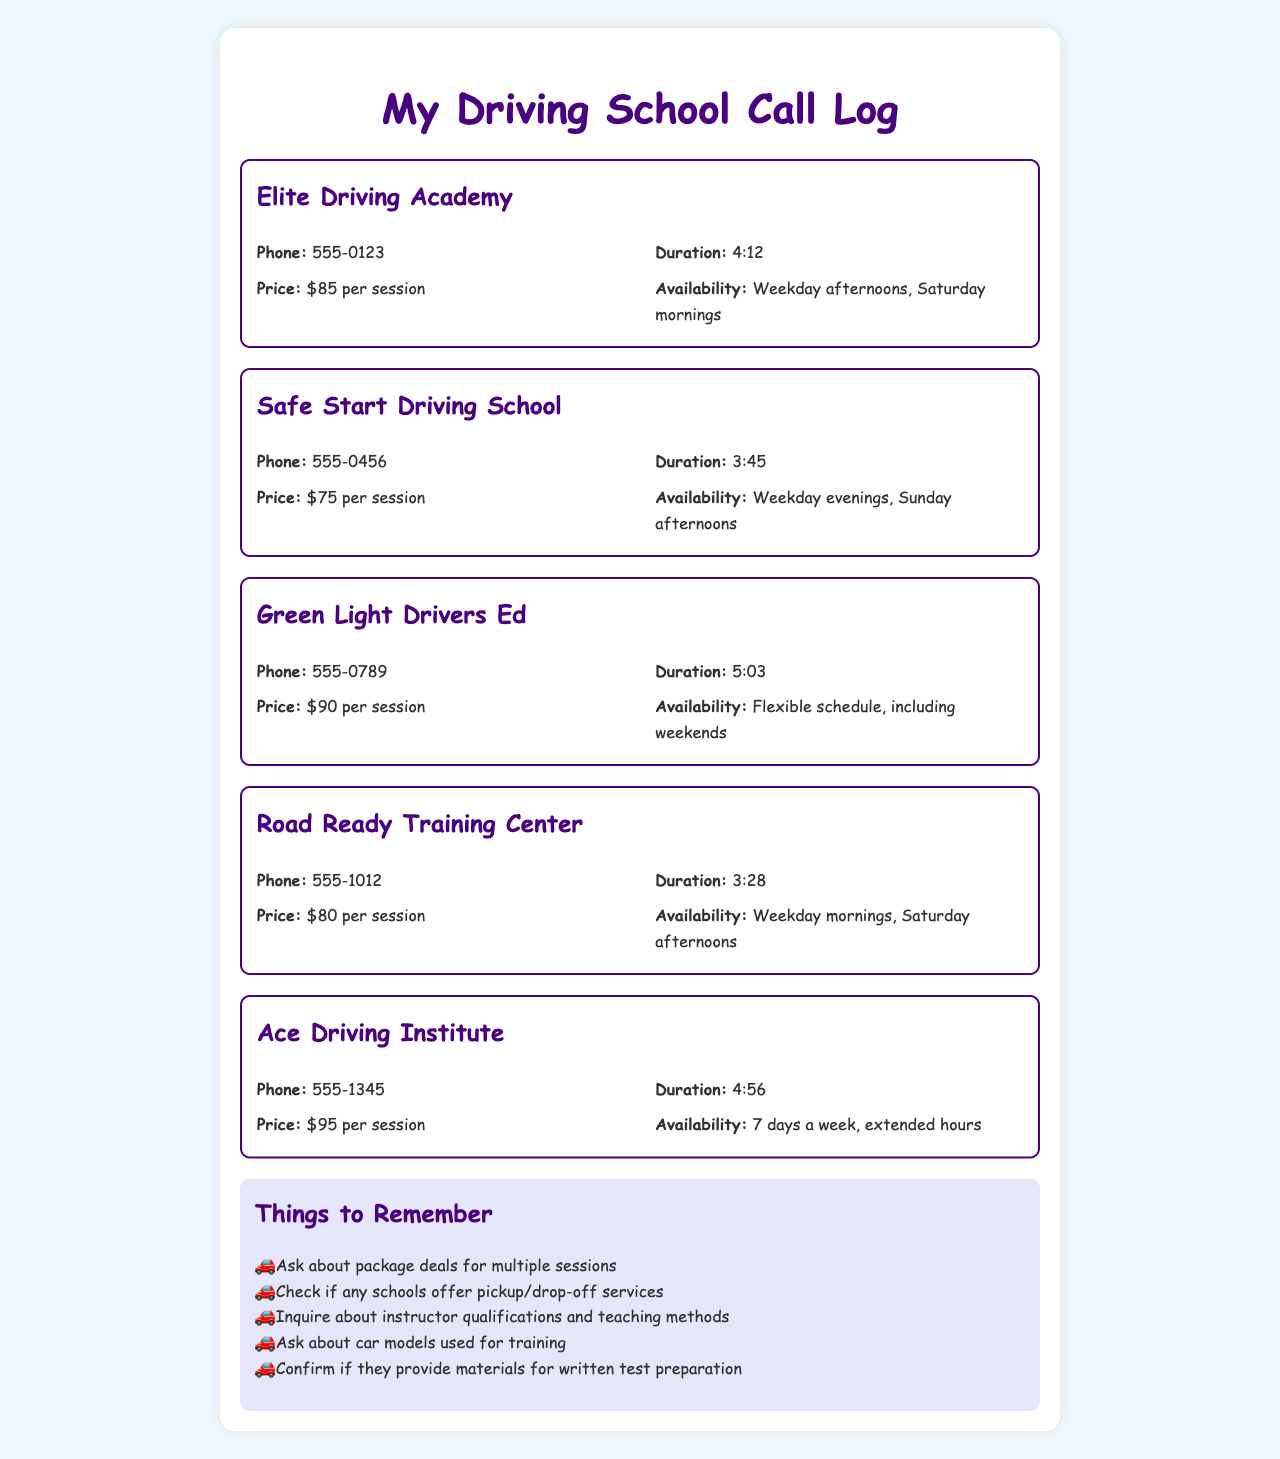What is the price per session at Safe Start Driving School? The price per session is specifically stated in the document for each driving school, which shows that Safe Start Driving School charges $75 per session.
Answer: $75 What phone number can be called for Elite Driving Academy? Each driving school has an associated phone number listed in the document. For Elite Driving Academy, the phone number is 555-0123.
Answer: 555-0123 Which driving school offers a flexible schedule? The document lists the availability of each driving school, indicating that Green Light Drivers Ed provides a flexible schedule, which includes weekends.
Answer: Flexible schedule How long was the call with Ace Driving Institute? The duration of each call is recorded in the document, with Ace Driving Institute showing a call length of 4:56.
Answer: 4:56 What days are available for sessions at Road Ready Training Center? The document includes availability details for each school. Road Ready Training Center's sessions are available on weekday mornings and Saturday afternoons.
Answer: Weekday mornings, Saturday afternoons Which school has the highest price per session? By comparing the prices from the document, it can be determined that Ace Driving Institute has the highest price at $95 per session.
Answer: $95 Are there any notes about what to ask the driving schools? The document contains a section titled "Things to Remember" which lists specific points to inquire about, such as package deals and instructor qualifications.
Answer: Yes What unique services should you check for at the driving schools? Among the things to remember, it's suggested to check for pickup/drop-off services and the materials provided for written test preparation.
Answer: Pickup/drop-off services, written test preparation What is the availability for driving sessions at Green Light Drivers Ed? The document specifies that Green Light Drivers Ed has a flexible schedule, meaning they can accommodate various times for driving sessions.
Answer: Flexible schedule 